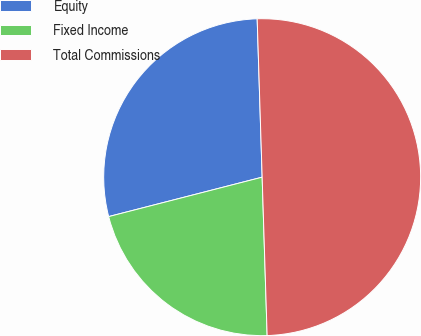Convert chart to OTSL. <chart><loc_0><loc_0><loc_500><loc_500><pie_chart><fcel>Equity<fcel>Fixed Income<fcel>Total Commissions<nl><fcel>28.5%<fcel>21.5%<fcel>50.0%<nl></chart> 